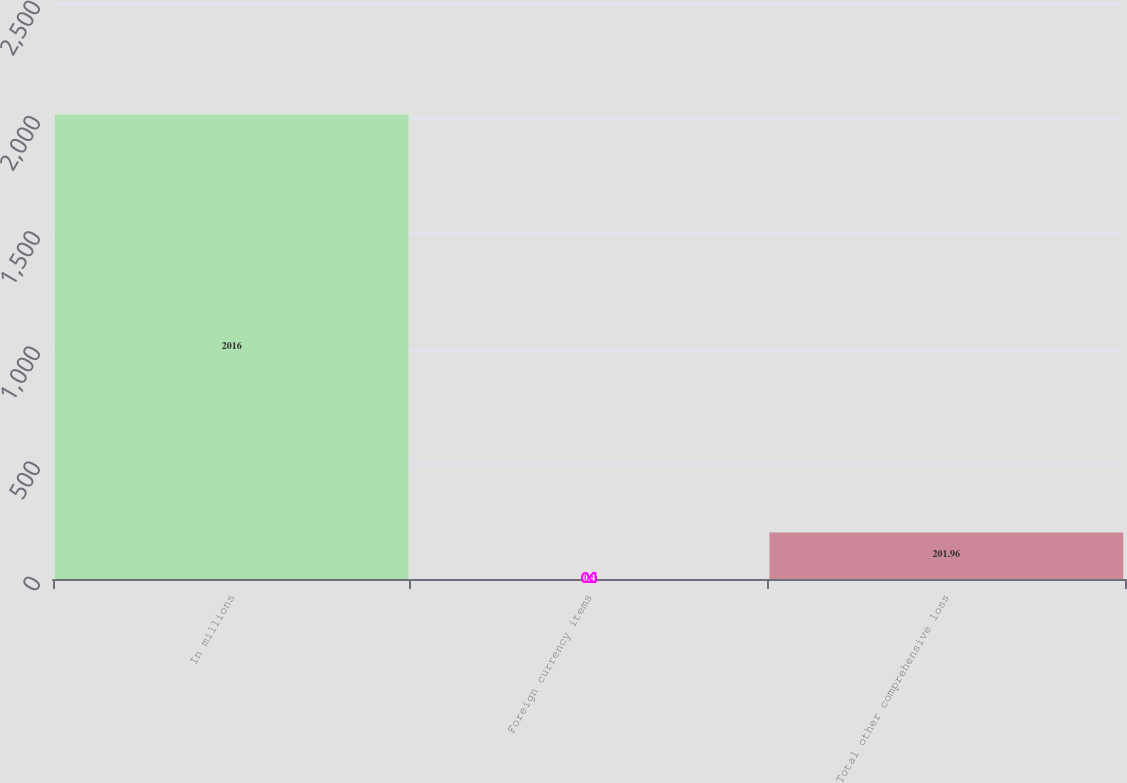<chart> <loc_0><loc_0><loc_500><loc_500><bar_chart><fcel>In millions<fcel>Foreign currency items<fcel>Total other comprehensive loss<nl><fcel>2016<fcel>0.4<fcel>201.96<nl></chart> 